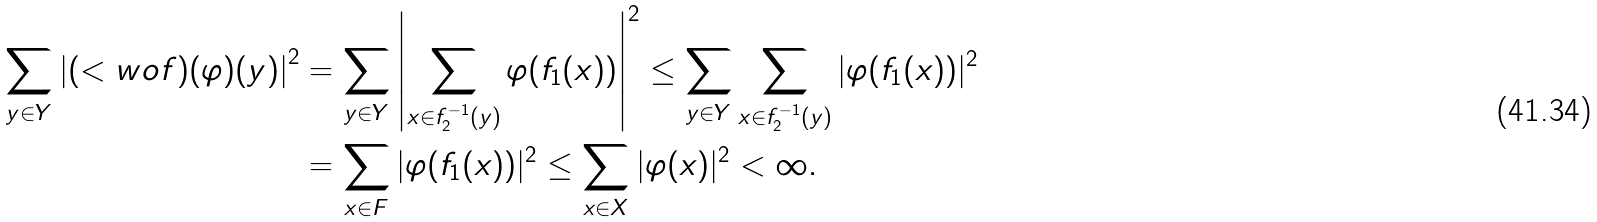Convert formula to latex. <formula><loc_0><loc_0><loc_500><loc_500>\sum _ { y \in Y } \left | ( < w o f ) ( \varphi ) ( y ) \right | ^ { 2 } & = \sum _ { y \in Y } \left | \sum _ { x \in f _ { 2 } ^ { - 1 } ( y ) } \varphi ( f _ { 1 } ( x ) ) \right | ^ { 2 } \leq \sum _ { y \in Y } \sum _ { x \in f _ { 2 } ^ { - 1 } ( y ) } | \varphi ( f _ { 1 } ( x ) ) | ^ { 2 } \\ & = \sum _ { x \in F } | \varphi ( f _ { 1 } ( x ) ) | ^ { 2 } \leq \sum _ { x \in X } | \varphi ( x ) | ^ { 2 } < \infty .</formula> 